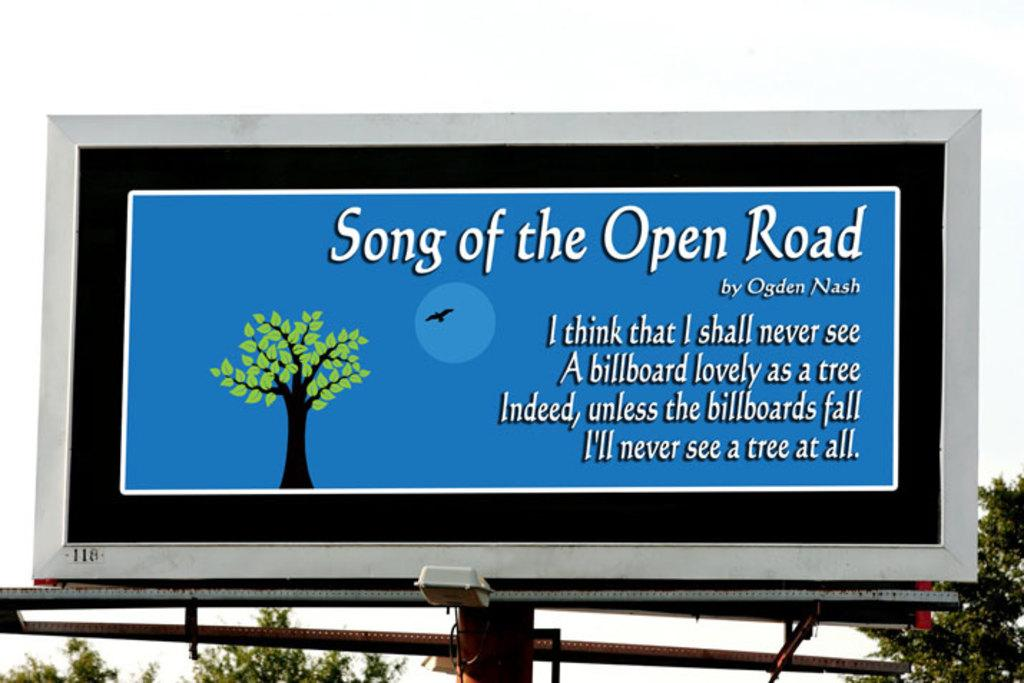Provide a one-sentence caption for the provided image. A billboard citing the lyrics of song of the open road. 